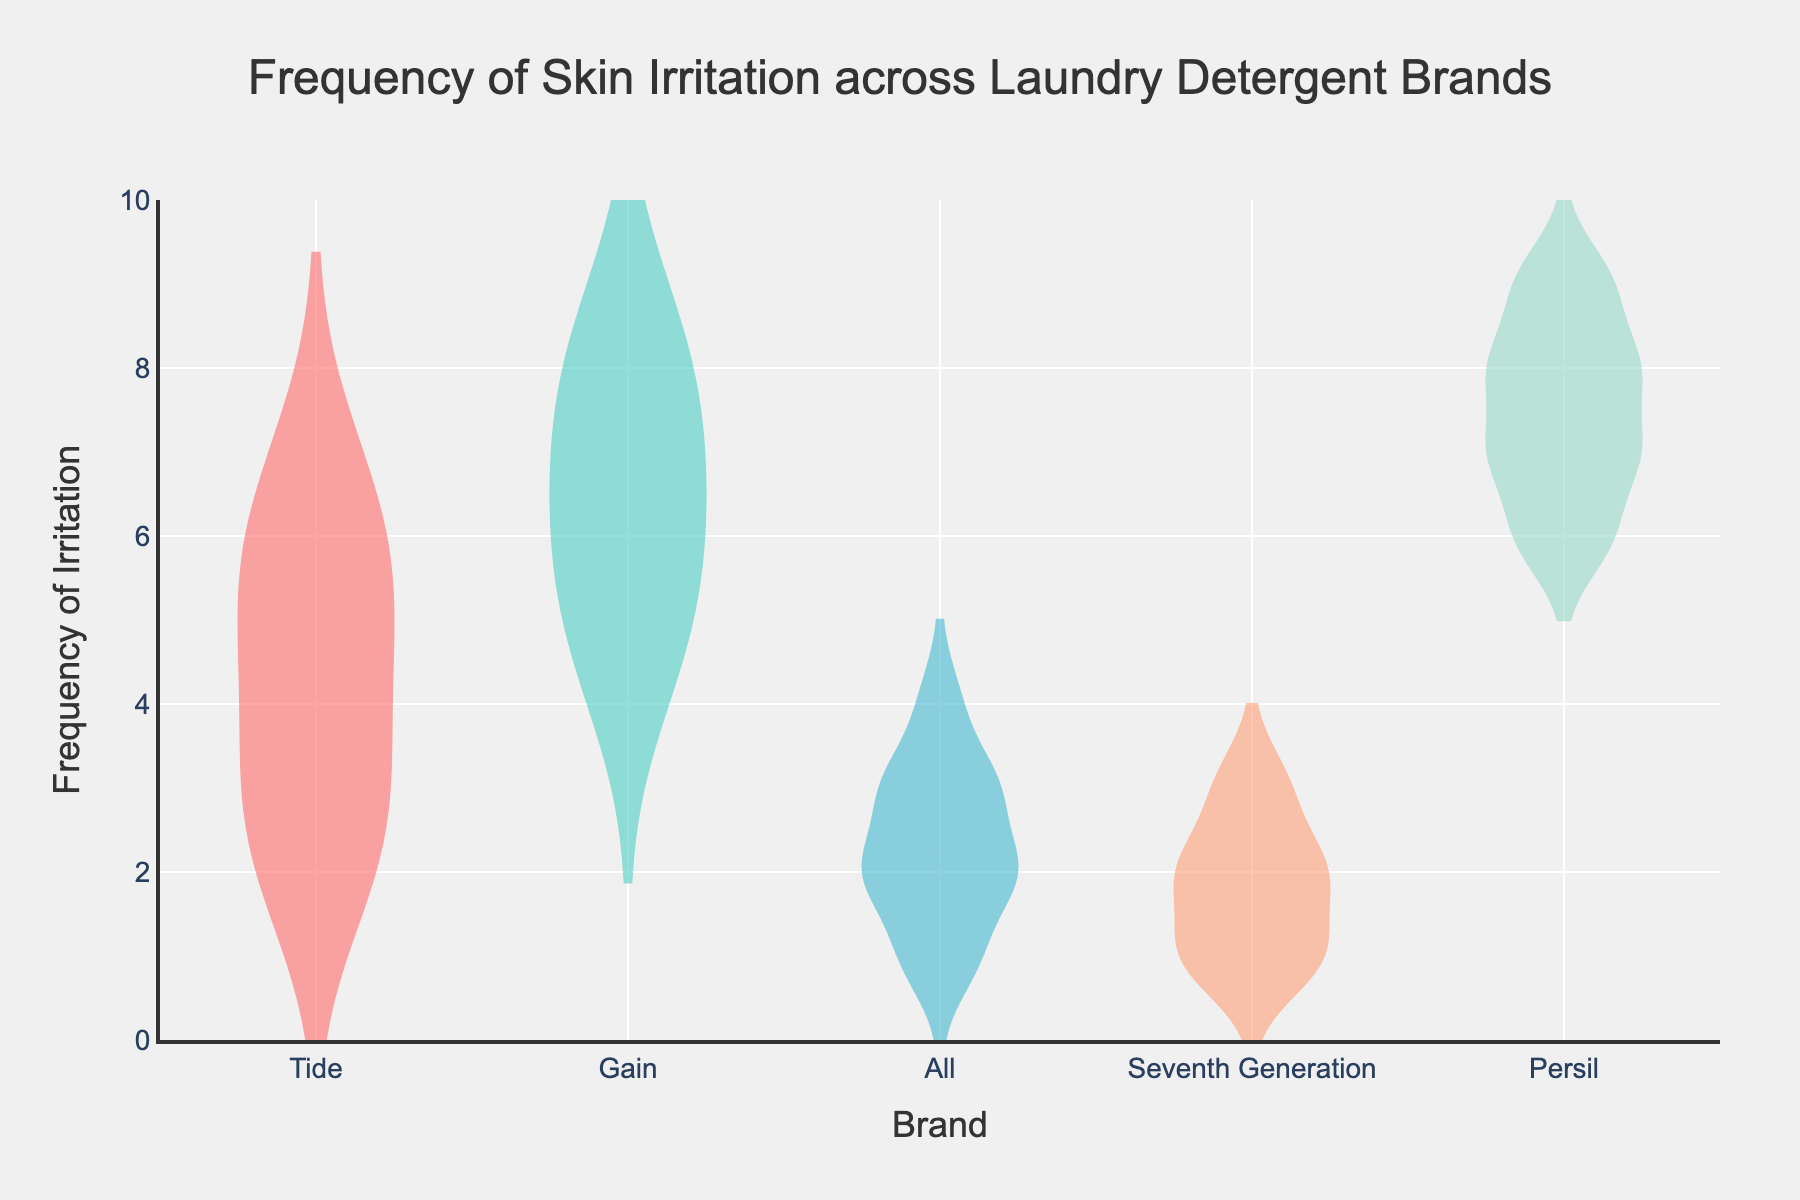What's the title of the figure? The title is typically found at the top of the figure and usually summarizes what the figure is about. In this case, it's provided in the code snippet to be 'Frequency of Skin Irritation across Laundry Detergent Brands'.
Answer: Frequency of Skin Irritation across Laundry Detergent Brands How many different laundry detergent brands are represented in the figure? By looking at the X-axis, which is labeled 'Brand', we can count the number of different brands displayed. This information correlates to the unique brands in the provided data: Tide, Gain, All, Seventh Generation, and Persil.
Answer: 5 Which brand shows the widest distribution of irritation frequencies? The brand with the widest distribution will have the largest spread in its violin plot. By comparing the widths, we can see which one spans the most along the Y-axis.
Answer: Gain What is the median frequency of irritation for Persil? To find the median, identify the middle value in the box plot over the violin plot for Persil. The median is marked by a line inside the box.
Answer: 7 Which brand has the lowest minimum frequency of irritation? The minimum frequency of irritation for each brand is identified at the bottommost point of the violin plot. By comparing these minimum values, we can deduce which is lowest.
Answer: All and Seventh Generation (tie) What is the range of irritation frequencies for Tide? The range is found by subtracting the minimum value from the maximum value within the Tide plot. Observe the lowest and highest points of Tide's violin plot.
Answer: 5 (7 - 2) Which brand has the highest mean frequency of irritation? The mean is indicated by the horizontal line within the boat-shaped mean line inside the violin plot. By comparing the mean lines, the highest mean value can be identified.
Answer: Persil How does the median irritation frequency of Gain compare to All? The medians are shown inside the box plot for each brand. Gain’s median is higher since it is visually higher on the Y-axis compared to All’s.
Answer: Gain's median is higher than All's Between Tide and Seventh Generation, which brand has a higher frequency spread? The spread can be determined by comparing the vertical lengths of the violin plots for Tide and Seventh Generation. Tide has a greater spread along the Y-axis.
Answer: Tide What is the most frequent irritation score for All? The most frequent value is where the violin plot is widest, indicating a higher density of data points. For All, this value is the mode of the data.
Answer: 2 